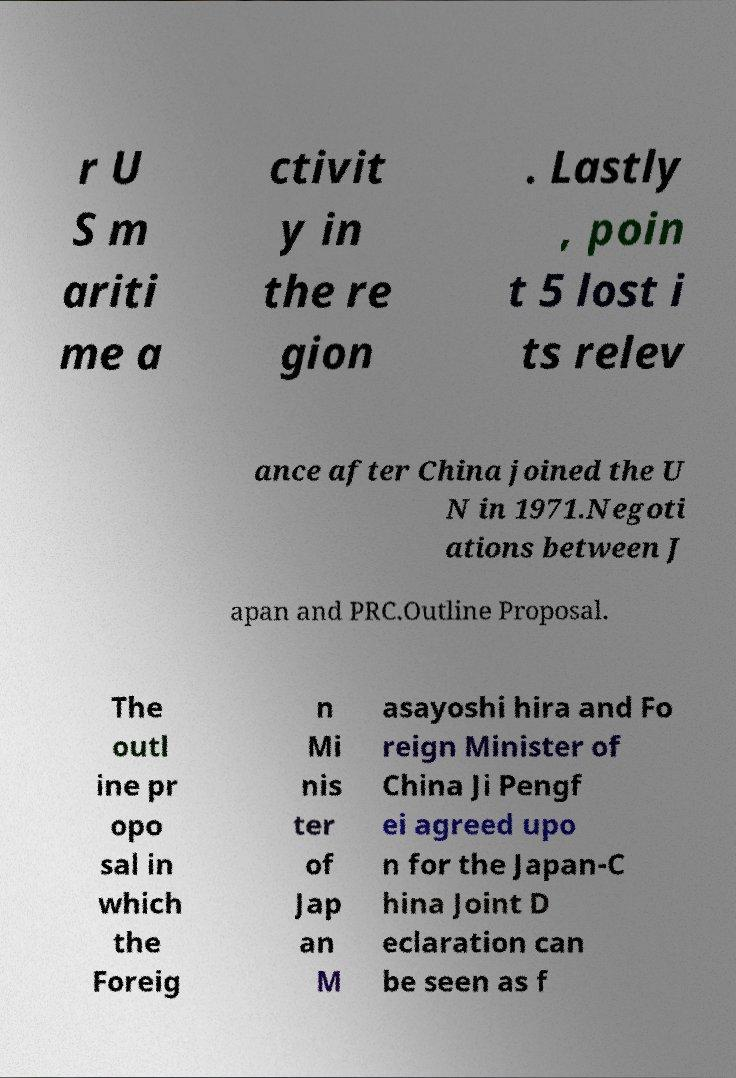Please identify and transcribe the text found in this image. r U S m ariti me a ctivit y in the re gion . Lastly , poin t 5 lost i ts relev ance after China joined the U N in 1971.Negoti ations between J apan and PRC.Outline Proposal. The outl ine pr opo sal in which the Foreig n Mi nis ter of Jap an M asayoshi hira and Fo reign Minister of China Ji Pengf ei agreed upo n for the Japan-C hina Joint D eclaration can be seen as f 